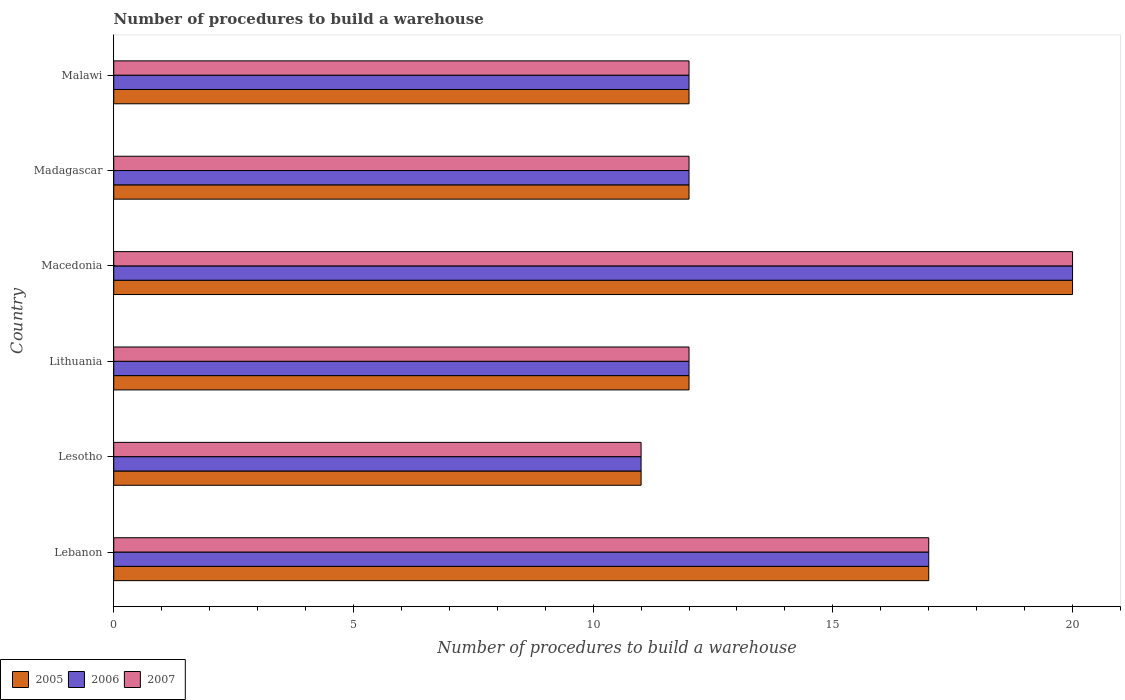How many different coloured bars are there?
Give a very brief answer. 3. How many groups of bars are there?
Offer a very short reply. 6. Are the number of bars per tick equal to the number of legend labels?
Keep it short and to the point. Yes. Are the number of bars on each tick of the Y-axis equal?
Your answer should be very brief. Yes. What is the label of the 1st group of bars from the top?
Your answer should be compact. Malawi. What is the number of procedures to build a warehouse in in 2006 in Macedonia?
Your answer should be compact. 20. Across all countries, what is the maximum number of procedures to build a warehouse in in 2005?
Offer a terse response. 20. Across all countries, what is the minimum number of procedures to build a warehouse in in 2005?
Give a very brief answer. 11. In which country was the number of procedures to build a warehouse in in 2007 maximum?
Provide a short and direct response. Macedonia. In which country was the number of procedures to build a warehouse in in 2006 minimum?
Make the answer very short. Lesotho. In how many countries, is the number of procedures to build a warehouse in in 2006 greater than 14 ?
Keep it short and to the point. 2. What is the ratio of the number of procedures to build a warehouse in in 2007 in Lebanon to that in Lesotho?
Provide a short and direct response. 1.55. What is the difference between the highest and the second highest number of procedures to build a warehouse in in 2007?
Keep it short and to the point. 3. What is the difference between the highest and the lowest number of procedures to build a warehouse in in 2006?
Your answer should be very brief. 9. In how many countries, is the number of procedures to build a warehouse in in 2006 greater than the average number of procedures to build a warehouse in in 2006 taken over all countries?
Your answer should be compact. 2. What does the 3rd bar from the top in Lesotho represents?
Ensure brevity in your answer.  2005. What does the 2nd bar from the bottom in Lithuania represents?
Your answer should be very brief. 2006. Is it the case that in every country, the sum of the number of procedures to build a warehouse in in 2007 and number of procedures to build a warehouse in in 2006 is greater than the number of procedures to build a warehouse in in 2005?
Provide a succinct answer. Yes. How many bars are there?
Provide a short and direct response. 18. Are all the bars in the graph horizontal?
Your response must be concise. Yes. What is the difference between two consecutive major ticks on the X-axis?
Your answer should be compact. 5. Are the values on the major ticks of X-axis written in scientific E-notation?
Give a very brief answer. No. Does the graph contain any zero values?
Offer a terse response. No. How are the legend labels stacked?
Your answer should be very brief. Horizontal. What is the title of the graph?
Your answer should be compact. Number of procedures to build a warehouse. What is the label or title of the X-axis?
Give a very brief answer. Number of procedures to build a warehouse. What is the label or title of the Y-axis?
Offer a terse response. Country. What is the Number of procedures to build a warehouse in 2005 in Lebanon?
Offer a terse response. 17. What is the Number of procedures to build a warehouse of 2007 in Lebanon?
Give a very brief answer. 17. What is the Number of procedures to build a warehouse of 2005 in Lesotho?
Give a very brief answer. 11. What is the Number of procedures to build a warehouse of 2007 in Lesotho?
Offer a very short reply. 11. What is the Number of procedures to build a warehouse of 2005 in Lithuania?
Provide a short and direct response. 12. What is the Number of procedures to build a warehouse of 2006 in Lithuania?
Provide a succinct answer. 12. What is the Number of procedures to build a warehouse in 2007 in Lithuania?
Keep it short and to the point. 12. What is the Number of procedures to build a warehouse of 2005 in Macedonia?
Your response must be concise. 20. What is the Number of procedures to build a warehouse in 2005 in Madagascar?
Give a very brief answer. 12. What is the Number of procedures to build a warehouse in 2006 in Madagascar?
Ensure brevity in your answer.  12. What is the Number of procedures to build a warehouse in 2005 in Malawi?
Make the answer very short. 12. What is the Number of procedures to build a warehouse in 2006 in Malawi?
Offer a terse response. 12. What is the Number of procedures to build a warehouse in 2007 in Malawi?
Keep it short and to the point. 12. Across all countries, what is the maximum Number of procedures to build a warehouse in 2005?
Keep it short and to the point. 20. Across all countries, what is the maximum Number of procedures to build a warehouse of 2007?
Offer a terse response. 20. Across all countries, what is the minimum Number of procedures to build a warehouse in 2005?
Make the answer very short. 11. Across all countries, what is the minimum Number of procedures to build a warehouse of 2006?
Your response must be concise. 11. What is the total Number of procedures to build a warehouse in 2006 in the graph?
Ensure brevity in your answer.  84. What is the difference between the Number of procedures to build a warehouse of 2007 in Lebanon and that in Lesotho?
Give a very brief answer. 6. What is the difference between the Number of procedures to build a warehouse in 2006 in Lebanon and that in Lithuania?
Give a very brief answer. 5. What is the difference between the Number of procedures to build a warehouse of 2007 in Lebanon and that in Lithuania?
Offer a very short reply. 5. What is the difference between the Number of procedures to build a warehouse in 2006 in Lebanon and that in Macedonia?
Your answer should be compact. -3. What is the difference between the Number of procedures to build a warehouse of 2005 in Lebanon and that in Madagascar?
Your answer should be compact. 5. What is the difference between the Number of procedures to build a warehouse in 2006 in Lebanon and that in Malawi?
Provide a short and direct response. 5. What is the difference between the Number of procedures to build a warehouse of 2005 in Lesotho and that in Macedonia?
Keep it short and to the point. -9. What is the difference between the Number of procedures to build a warehouse of 2006 in Lesotho and that in Madagascar?
Ensure brevity in your answer.  -1. What is the difference between the Number of procedures to build a warehouse in 2005 in Lithuania and that in Macedonia?
Offer a terse response. -8. What is the difference between the Number of procedures to build a warehouse of 2007 in Lithuania and that in Macedonia?
Keep it short and to the point. -8. What is the difference between the Number of procedures to build a warehouse of 2007 in Lithuania and that in Madagascar?
Your answer should be very brief. 0. What is the difference between the Number of procedures to build a warehouse in 2005 in Lithuania and that in Malawi?
Make the answer very short. 0. What is the difference between the Number of procedures to build a warehouse of 2005 in Macedonia and that in Madagascar?
Your response must be concise. 8. What is the difference between the Number of procedures to build a warehouse in 2007 in Macedonia and that in Madagascar?
Offer a terse response. 8. What is the difference between the Number of procedures to build a warehouse in 2007 in Macedonia and that in Malawi?
Ensure brevity in your answer.  8. What is the difference between the Number of procedures to build a warehouse in 2005 in Lebanon and the Number of procedures to build a warehouse in 2006 in Lesotho?
Offer a terse response. 6. What is the difference between the Number of procedures to build a warehouse in 2006 in Lebanon and the Number of procedures to build a warehouse in 2007 in Lesotho?
Your answer should be compact. 6. What is the difference between the Number of procedures to build a warehouse of 2005 in Lebanon and the Number of procedures to build a warehouse of 2006 in Lithuania?
Offer a terse response. 5. What is the difference between the Number of procedures to build a warehouse in 2006 in Lebanon and the Number of procedures to build a warehouse in 2007 in Lithuania?
Give a very brief answer. 5. What is the difference between the Number of procedures to build a warehouse of 2005 in Lebanon and the Number of procedures to build a warehouse of 2006 in Macedonia?
Make the answer very short. -3. What is the difference between the Number of procedures to build a warehouse of 2005 in Lebanon and the Number of procedures to build a warehouse of 2007 in Macedonia?
Your answer should be very brief. -3. What is the difference between the Number of procedures to build a warehouse of 2006 in Lebanon and the Number of procedures to build a warehouse of 2007 in Madagascar?
Offer a very short reply. 5. What is the difference between the Number of procedures to build a warehouse in 2005 in Lebanon and the Number of procedures to build a warehouse in 2006 in Malawi?
Provide a short and direct response. 5. What is the difference between the Number of procedures to build a warehouse in 2005 in Lesotho and the Number of procedures to build a warehouse in 2007 in Lithuania?
Give a very brief answer. -1. What is the difference between the Number of procedures to build a warehouse of 2005 in Lesotho and the Number of procedures to build a warehouse of 2006 in Macedonia?
Your response must be concise. -9. What is the difference between the Number of procedures to build a warehouse of 2005 in Lesotho and the Number of procedures to build a warehouse of 2006 in Madagascar?
Provide a succinct answer. -1. What is the difference between the Number of procedures to build a warehouse of 2005 in Lesotho and the Number of procedures to build a warehouse of 2007 in Madagascar?
Provide a short and direct response. -1. What is the difference between the Number of procedures to build a warehouse in 2006 in Lesotho and the Number of procedures to build a warehouse in 2007 in Madagascar?
Ensure brevity in your answer.  -1. What is the difference between the Number of procedures to build a warehouse of 2005 in Lithuania and the Number of procedures to build a warehouse of 2006 in Macedonia?
Your answer should be very brief. -8. What is the difference between the Number of procedures to build a warehouse of 2005 in Lithuania and the Number of procedures to build a warehouse of 2007 in Macedonia?
Provide a succinct answer. -8. What is the difference between the Number of procedures to build a warehouse in 2006 in Lithuania and the Number of procedures to build a warehouse in 2007 in Madagascar?
Offer a terse response. 0. What is the difference between the Number of procedures to build a warehouse in 2005 in Lithuania and the Number of procedures to build a warehouse in 2006 in Malawi?
Offer a terse response. 0. What is the difference between the Number of procedures to build a warehouse in 2005 in Lithuania and the Number of procedures to build a warehouse in 2007 in Malawi?
Provide a succinct answer. 0. What is the difference between the Number of procedures to build a warehouse in 2006 in Lithuania and the Number of procedures to build a warehouse in 2007 in Malawi?
Offer a terse response. 0. What is the difference between the Number of procedures to build a warehouse of 2006 in Macedonia and the Number of procedures to build a warehouse of 2007 in Madagascar?
Offer a very short reply. 8. What is the difference between the Number of procedures to build a warehouse of 2005 in Macedonia and the Number of procedures to build a warehouse of 2006 in Malawi?
Offer a very short reply. 8. What is the difference between the Number of procedures to build a warehouse in 2005 in Macedonia and the Number of procedures to build a warehouse in 2007 in Malawi?
Your response must be concise. 8. What is the difference between the Number of procedures to build a warehouse of 2005 in Madagascar and the Number of procedures to build a warehouse of 2007 in Malawi?
Offer a terse response. 0. What is the difference between the Number of procedures to build a warehouse in 2006 in Madagascar and the Number of procedures to build a warehouse in 2007 in Malawi?
Give a very brief answer. 0. What is the average Number of procedures to build a warehouse of 2005 per country?
Offer a very short reply. 14. What is the difference between the Number of procedures to build a warehouse in 2006 and Number of procedures to build a warehouse in 2007 in Lebanon?
Your answer should be very brief. 0. What is the difference between the Number of procedures to build a warehouse of 2005 and Number of procedures to build a warehouse of 2006 in Lesotho?
Give a very brief answer. 0. What is the difference between the Number of procedures to build a warehouse in 2005 and Number of procedures to build a warehouse in 2007 in Lesotho?
Your answer should be compact. 0. What is the difference between the Number of procedures to build a warehouse in 2005 and Number of procedures to build a warehouse in 2007 in Lithuania?
Provide a succinct answer. 0. What is the difference between the Number of procedures to build a warehouse in 2005 and Number of procedures to build a warehouse in 2006 in Macedonia?
Provide a short and direct response. 0. What is the difference between the Number of procedures to build a warehouse in 2005 and Number of procedures to build a warehouse in 2006 in Madagascar?
Your response must be concise. 0. What is the difference between the Number of procedures to build a warehouse in 2005 and Number of procedures to build a warehouse in 2006 in Malawi?
Your answer should be very brief. 0. What is the ratio of the Number of procedures to build a warehouse of 2005 in Lebanon to that in Lesotho?
Keep it short and to the point. 1.55. What is the ratio of the Number of procedures to build a warehouse of 2006 in Lebanon to that in Lesotho?
Keep it short and to the point. 1.55. What is the ratio of the Number of procedures to build a warehouse of 2007 in Lebanon to that in Lesotho?
Provide a short and direct response. 1.55. What is the ratio of the Number of procedures to build a warehouse of 2005 in Lebanon to that in Lithuania?
Your answer should be compact. 1.42. What is the ratio of the Number of procedures to build a warehouse in 2006 in Lebanon to that in Lithuania?
Provide a succinct answer. 1.42. What is the ratio of the Number of procedures to build a warehouse of 2007 in Lebanon to that in Lithuania?
Your answer should be compact. 1.42. What is the ratio of the Number of procedures to build a warehouse of 2005 in Lebanon to that in Macedonia?
Offer a very short reply. 0.85. What is the ratio of the Number of procedures to build a warehouse in 2007 in Lebanon to that in Macedonia?
Give a very brief answer. 0.85. What is the ratio of the Number of procedures to build a warehouse in 2005 in Lebanon to that in Madagascar?
Provide a succinct answer. 1.42. What is the ratio of the Number of procedures to build a warehouse of 2006 in Lebanon to that in Madagascar?
Keep it short and to the point. 1.42. What is the ratio of the Number of procedures to build a warehouse of 2007 in Lebanon to that in Madagascar?
Give a very brief answer. 1.42. What is the ratio of the Number of procedures to build a warehouse of 2005 in Lebanon to that in Malawi?
Your response must be concise. 1.42. What is the ratio of the Number of procedures to build a warehouse of 2006 in Lebanon to that in Malawi?
Provide a short and direct response. 1.42. What is the ratio of the Number of procedures to build a warehouse of 2007 in Lebanon to that in Malawi?
Offer a very short reply. 1.42. What is the ratio of the Number of procedures to build a warehouse of 2005 in Lesotho to that in Lithuania?
Offer a very short reply. 0.92. What is the ratio of the Number of procedures to build a warehouse of 2007 in Lesotho to that in Lithuania?
Keep it short and to the point. 0.92. What is the ratio of the Number of procedures to build a warehouse of 2005 in Lesotho to that in Macedonia?
Provide a succinct answer. 0.55. What is the ratio of the Number of procedures to build a warehouse of 2006 in Lesotho to that in Macedonia?
Make the answer very short. 0.55. What is the ratio of the Number of procedures to build a warehouse in 2007 in Lesotho to that in Macedonia?
Provide a short and direct response. 0.55. What is the ratio of the Number of procedures to build a warehouse of 2006 in Lesotho to that in Madagascar?
Your answer should be compact. 0.92. What is the ratio of the Number of procedures to build a warehouse in 2007 in Lesotho to that in Madagascar?
Your answer should be compact. 0.92. What is the ratio of the Number of procedures to build a warehouse in 2005 in Lesotho to that in Malawi?
Keep it short and to the point. 0.92. What is the ratio of the Number of procedures to build a warehouse of 2006 in Lesotho to that in Malawi?
Give a very brief answer. 0.92. What is the ratio of the Number of procedures to build a warehouse in 2007 in Lesotho to that in Malawi?
Your answer should be very brief. 0.92. What is the ratio of the Number of procedures to build a warehouse of 2005 in Lithuania to that in Macedonia?
Keep it short and to the point. 0.6. What is the ratio of the Number of procedures to build a warehouse of 2007 in Lithuania to that in Macedonia?
Your answer should be compact. 0.6. What is the ratio of the Number of procedures to build a warehouse of 2005 in Lithuania to that in Madagascar?
Make the answer very short. 1. What is the ratio of the Number of procedures to build a warehouse in 2007 in Lithuania to that in Madagascar?
Keep it short and to the point. 1. What is the ratio of the Number of procedures to build a warehouse in 2005 in Lithuania to that in Malawi?
Your answer should be very brief. 1. What is the ratio of the Number of procedures to build a warehouse of 2006 in Lithuania to that in Malawi?
Keep it short and to the point. 1. What is the ratio of the Number of procedures to build a warehouse in 2007 in Lithuania to that in Malawi?
Offer a terse response. 1. What is the ratio of the Number of procedures to build a warehouse of 2007 in Macedonia to that in Malawi?
Offer a very short reply. 1.67. What is the ratio of the Number of procedures to build a warehouse of 2006 in Madagascar to that in Malawi?
Offer a very short reply. 1. What is the difference between the highest and the second highest Number of procedures to build a warehouse in 2005?
Your answer should be compact. 3. What is the difference between the highest and the second highest Number of procedures to build a warehouse of 2006?
Your response must be concise. 3. What is the difference between the highest and the lowest Number of procedures to build a warehouse in 2007?
Keep it short and to the point. 9. 